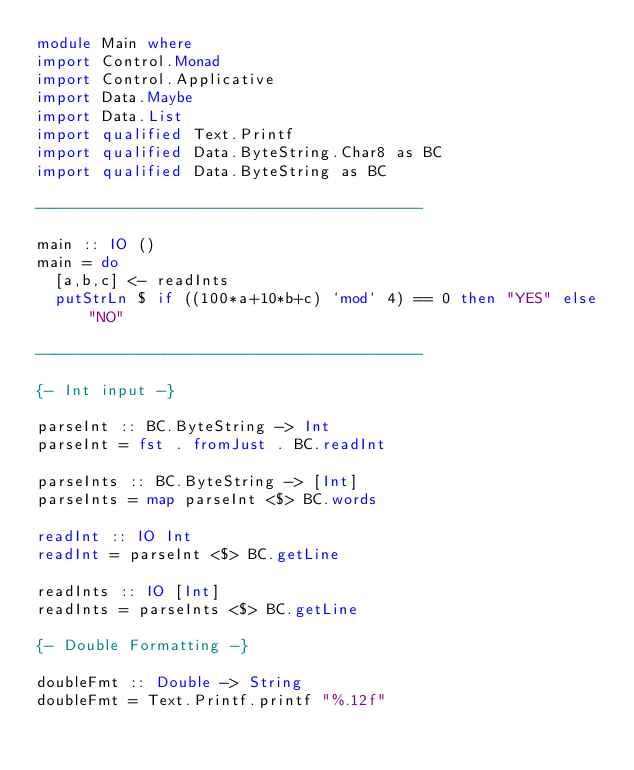Convert code to text. <code><loc_0><loc_0><loc_500><loc_500><_Haskell_>module Main where
import Control.Monad
import Control.Applicative
import Data.Maybe
import Data.List
import qualified Text.Printf
import qualified Data.ByteString.Char8 as BC
import qualified Data.ByteString as BC

------------------------------------------

main :: IO ()
main = do
  [a,b,c] <- readInts
  putStrLn $ if ((100*a+10*b+c) `mod` 4) == 0 then "YES" else "NO"

------------------------------------------

{- Int input -}

parseInt :: BC.ByteString -> Int
parseInt = fst . fromJust . BC.readInt

parseInts :: BC.ByteString -> [Int]
parseInts = map parseInt <$> BC.words

readInt :: IO Int
readInt = parseInt <$> BC.getLine

readInts :: IO [Int]
readInts = parseInts <$> BC.getLine

{- Double Formatting -}

doubleFmt :: Double -> String
doubleFmt = Text.Printf.printf "%.12f"
</code> 